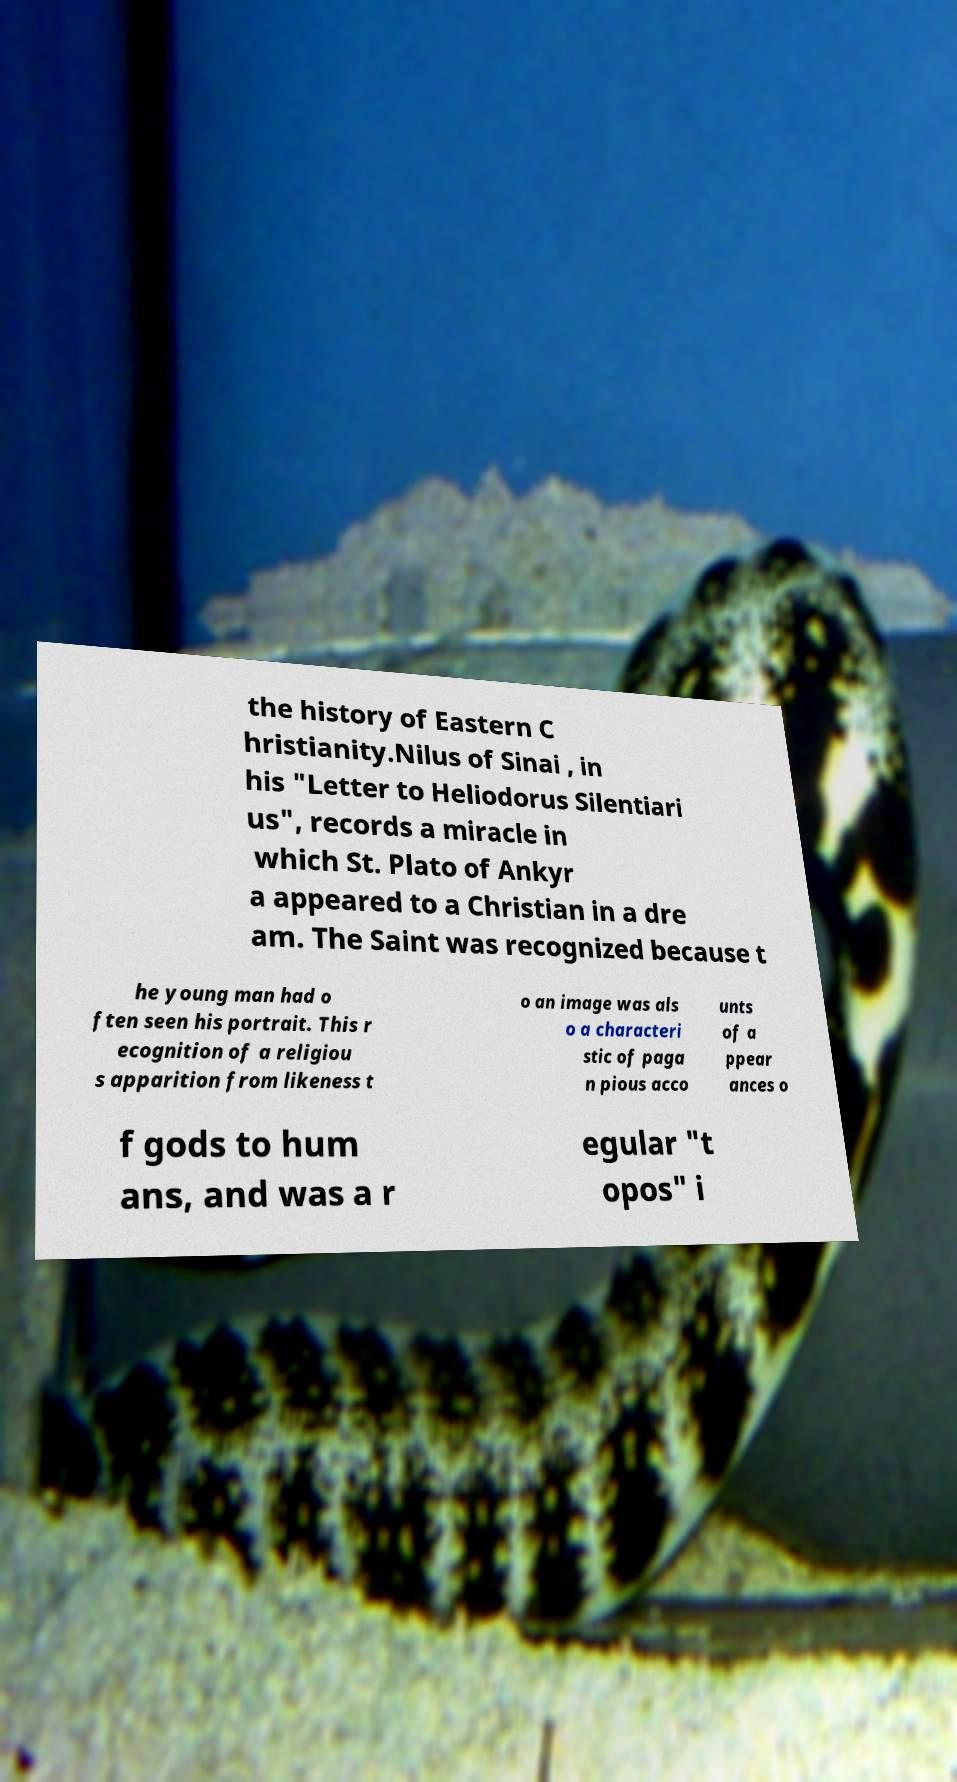Could you assist in decoding the text presented in this image and type it out clearly? the history of Eastern C hristianity.Nilus of Sinai , in his "Letter to Heliodorus Silentiari us", records a miracle in which St. Plato of Ankyr a appeared to a Christian in a dre am. The Saint was recognized because t he young man had o ften seen his portrait. This r ecognition of a religiou s apparition from likeness t o an image was als o a characteri stic of paga n pious acco unts of a ppear ances o f gods to hum ans, and was a r egular "t opos" i 